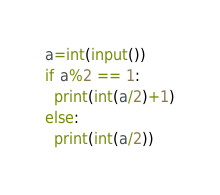Convert code to text. <code><loc_0><loc_0><loc_500><loc_500><_Python_>a=int(input())
if a%2 == 1:
  print(int(a/2)+1)
else:
  print(int(a/2))</code> 